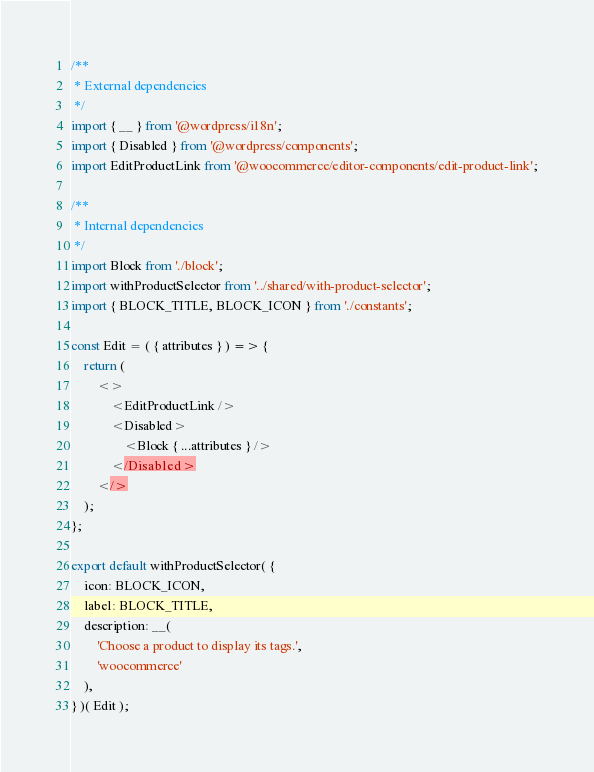Convert code to text. <code><loc_0><loc_0><loc_500><loc_500><_JavaScript_>/**
 * External dependencies
 */
import { __ } from '@wordpress/i18n';
import { Disabled } from '@wordpress/components';
import EditProductLink from '@woocommerce/editor-components/edit-product-link';

/**
 * Internal dependencies
 */
import Block from './block';
import withProductSelector from '../shared/with-product-selector';
import { BLOCK_TITLE, BLOCK_ICON } from './constants';

const Edit = ( { attributes } ) => {
	return (
		<>
			<EditProductLink />
			<Disabled>
				<Block { ...attributes } />
			</Disabled>
		</>
	);
};

export default withProductSelector( {
	icon: BLOCK_ICON,
	label: BLOCK_TITLE,
	description: __(
		'Choose a product to display its tags.',
		'woocommerce'
	),
} )( Edit );
</code> 